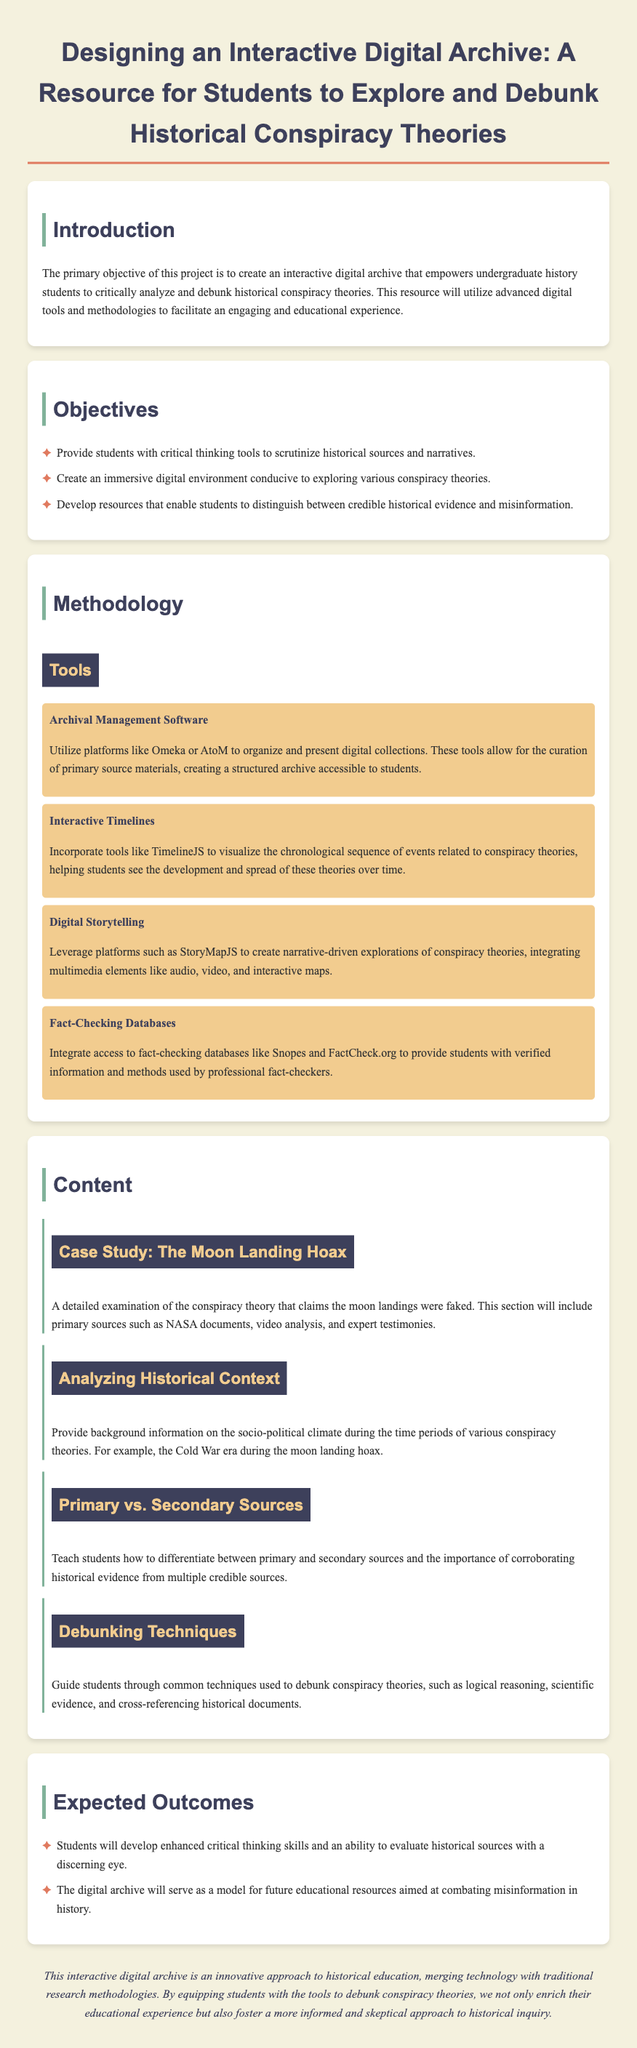what is the primary objective of the project? The primary objective is to create an interactive digital archive that empowers undergraduate history students to critically analyze and debunk historical conspiracy theories.
Answer: create an interactive digital archive name one tool used for archival management software. The proposal mentions platforms like Omeka or AtoM for archival management.
Answer: Omeka how many objectives are listed in the document? The document lists three main objectives for the project.
Answer: three what is a case study mentioned in the content section? The case study discussed relates to the conspiracy theory regarding the moon landing hoax.
Answer: The Moon Landing Hoax which methodology focuses on visualizing chronological sequences? The methodology utilizing visual elements to represent events is Interactive Timelines.
Answer: Interactive Timelines what is the expected outcome regarding students' skills? One of the expected outcomes is that students will develop enhanced critical thinking skills.
Answer: enhanced critical thinking skills what digital storytelling platform is mentioned? The document refers to StoryMapJS as a platform for digital storytelling.
Answer: StoryMapJS name one technique for debunking conspiracy theories. Common techniques for debunking include logical reasoning and scientific evidence.
Answer: logical reasoning 